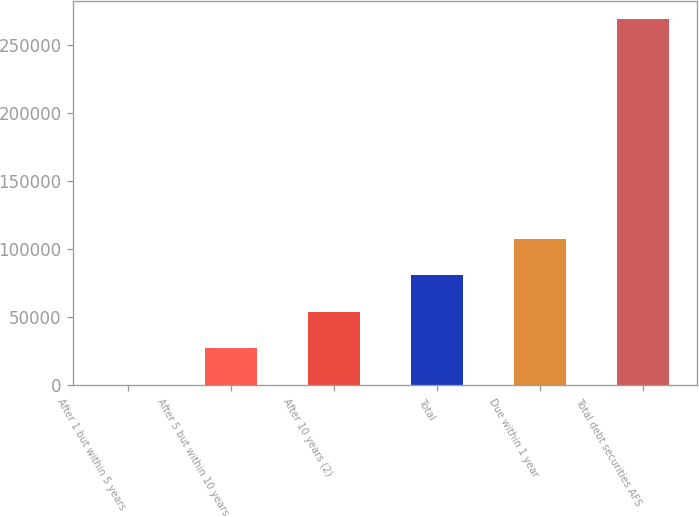<chart> <loc_0><loc_0><loc_500><loc_500><bar_chart><fcel>After 1 but within 5 years<fcel>After 5 but within 10 years<fcel>After 10 years (2)<fcel>Total<fcel>Due within 1 year<fcel>Total debt securities AFS<nl><fcel>375<fcel>27198.7<fcel>54022.4<fcel>80846.1<fcel>107670<fcel>268612<nl></chart> 